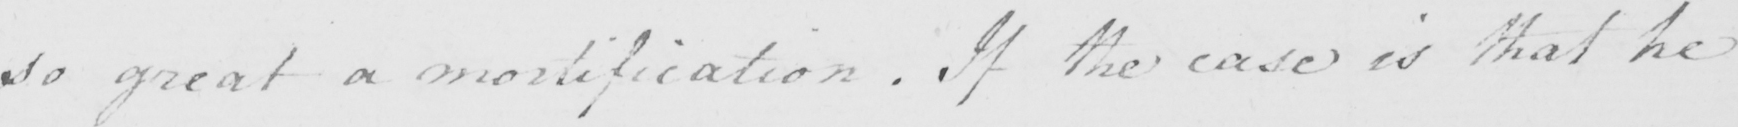Please transcribe the handwritten text in this image. so great a mortification . If the case is that he 